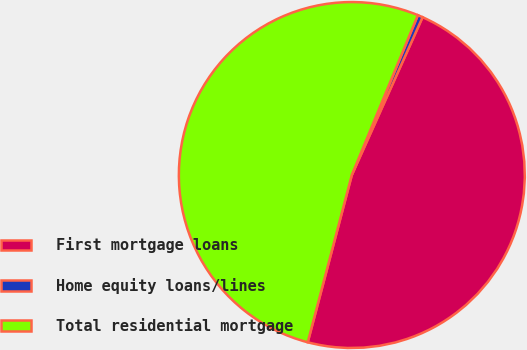Convert chart. <chart><loc_0><loc_0><loc_500><loc_500><pie_chart><fcel>First mortgage loans<fcel>Home equity loans/lines<fcel>Total residential mortgage<nl><fcel>47.4%<fcel>0.47%<fcel>52.14%<nl></chart> 